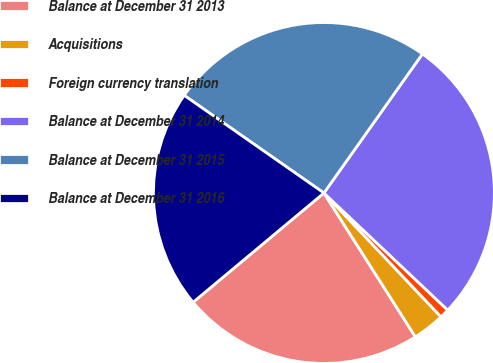Convert chart. <chart><loc_0><loc_0><loc_500><loc_500><pie_chart><fcel>Balance at December 31 2013<fcel>Acquisitions<fcel>Foreign currency translation<fcel>Balance at December 31 2014<fcel>Balance at December 31 2015<fcel>Balance at December 31 2016<nl><fcel>22.94%<fcel>3.04%<fcel>0.89%<fcel>27.25%<fcel>25.1%<fcel>20.78%<nl></chart> 